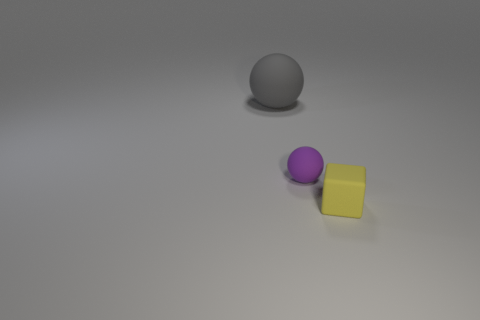Add 3 green metallic blocks. How many objects exist? 6 Subtract all cubes. How many objects are left? 2 Subtract 0 cyan balls. How many objects are left? 3 Subtract all small yellow things. Subtract all big gray rubber things. How many objects are left? 1 Add 1 matte balls. How many matte balls are left? 3 Add 1 big gray rubber balls. How many big gray rubber balls exist? 2 